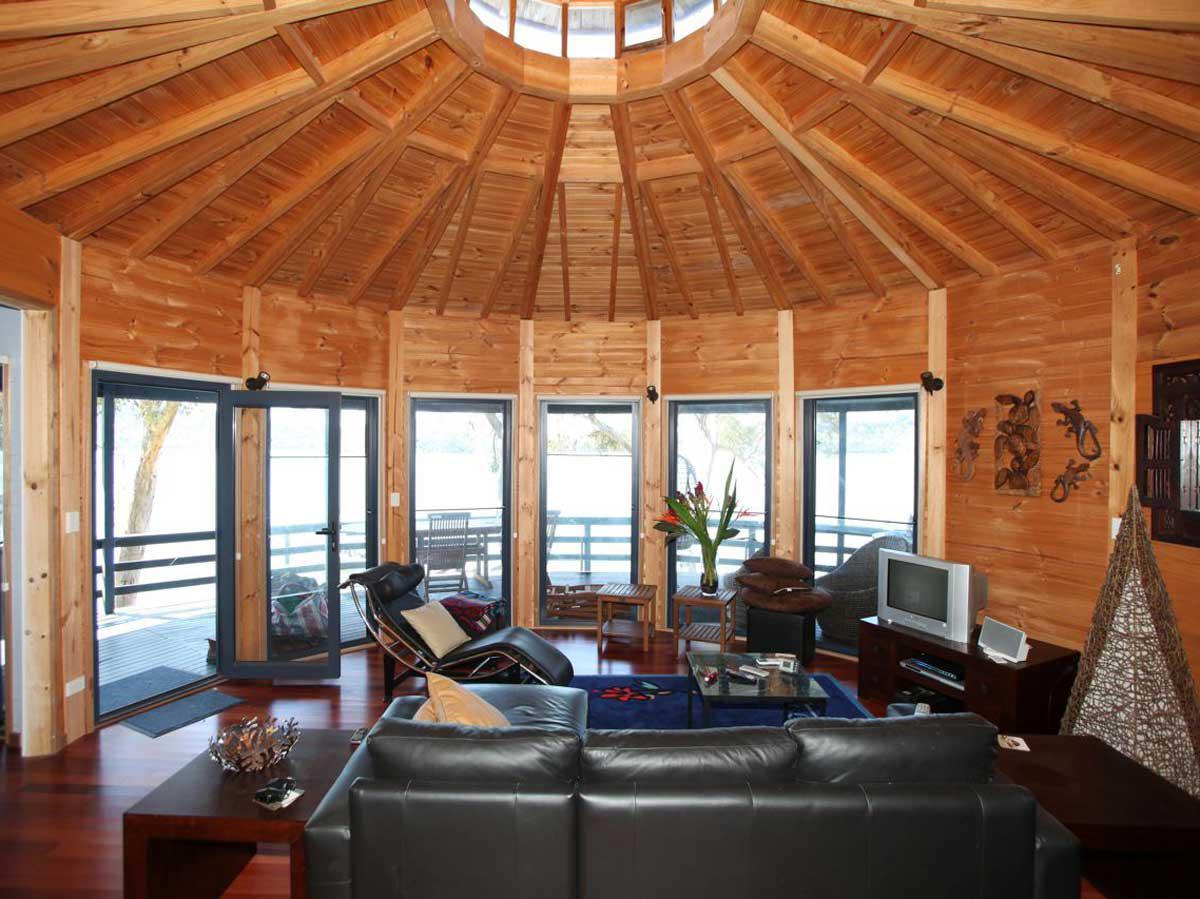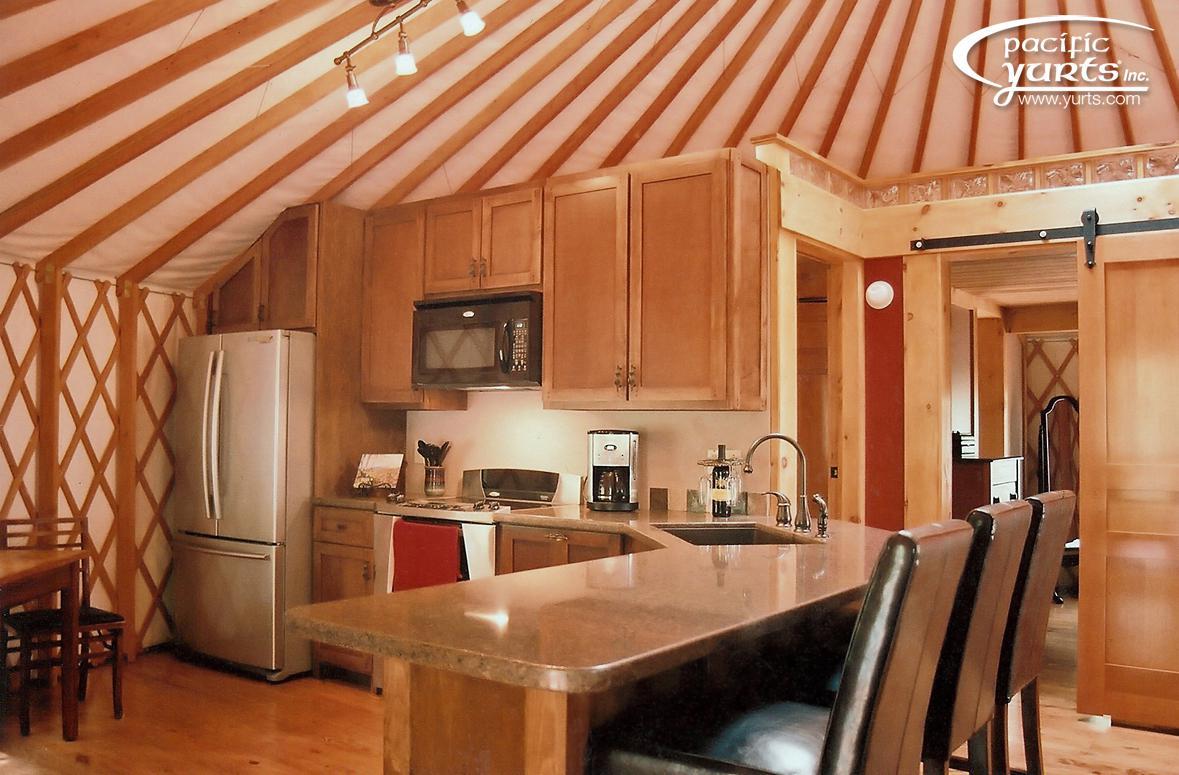The first image is the image on the left, the second image is the image on the right. Evaluate the accuracy of this statement regarding the images: "At least one room has a patterned oriental-type rug on the floor.". Is it true? Answer yes or no. No. 